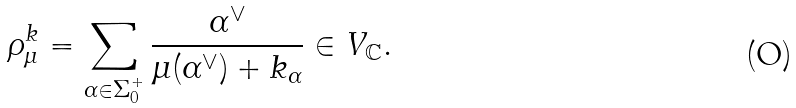Convert formula to latex. <formula><loc_0><loc_0><loc_500><loc_500>\rho _ { \mu } ^ { k } = \sum _ { \alpha \in \Sigma _ { 0 } ^ { + } } \frac { \alpha ^ { \vee } } { \mu ( \alpha ^ { \vee } ) + k _ { \alpha } } \in V _ { \mathbb { C } } .</formula> 